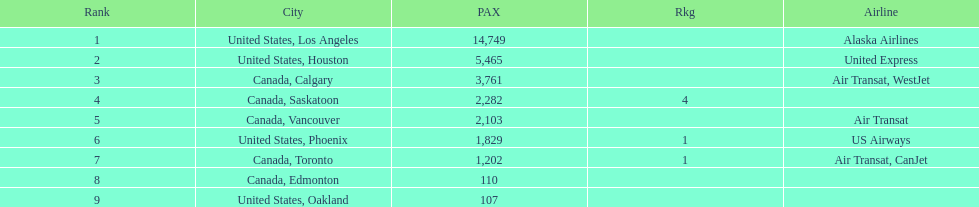What was the number of passengers in phoenix arizona? 1,829. 